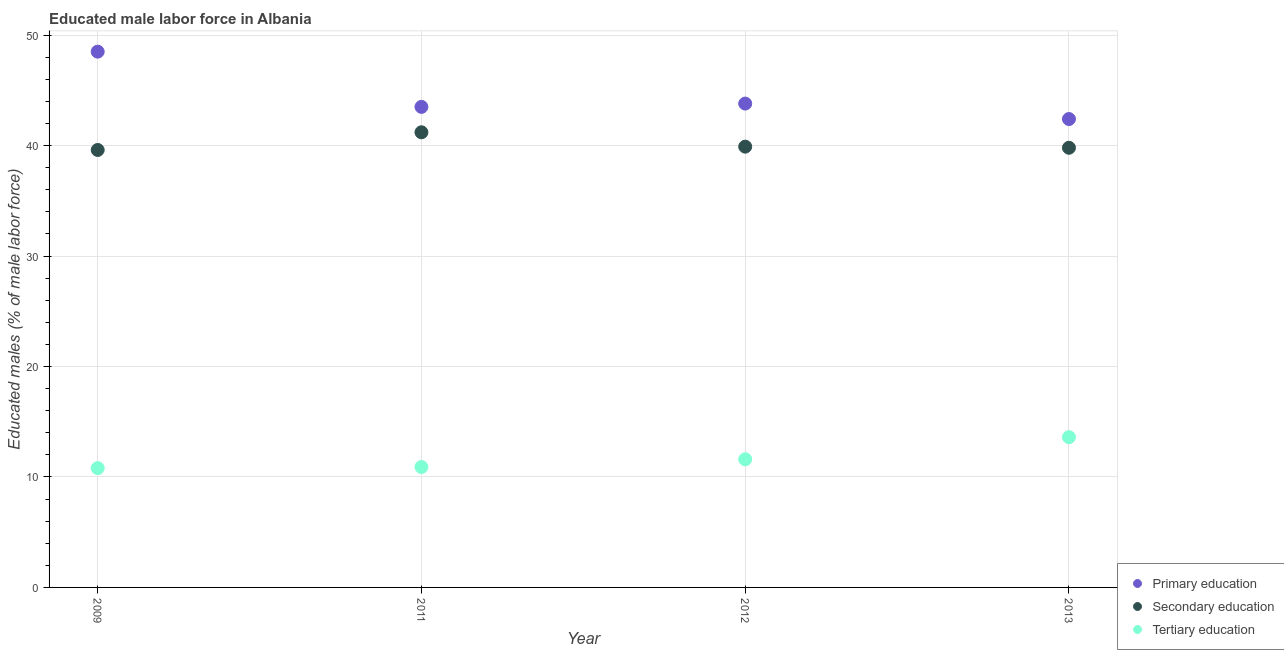Is the number of dotlines equal to the number of legend labels?
Keep it short and to the point. Yes. What is the percentage of male labor force who received secondary education in 2009?
Keep it short and to the point. 39.6. Across all years, what is the maximum percentage of male labor force who received primary education?
Keep it short and to the point. 48.5. Across all years, what is the minimum percentage of male labor force who received primary education?
Give a very brief answer. 42.4. In which year was the percentage of male labor force who received secondary education maximum?
Provide a short and direct response. 2011. What is the total percentage of male labor force who received primary education in the graph?
Ensure brevity in your answer.  178.2. What is the difference between the percentage of male labor force who received secondary education in 2011 and that in 2012?
Offer a terse response. 1.3. What is the difference between the percentage of male labor force who received secondary education in 2011 and the percentage of male labor force who received tertiary education in 2012?
Make the answer very short. 29.6. What is the average percentage of male labor force who received tertiary education per year?
Provide a short and direct response. 11.73. In the year 2009, what is the difference between the percentage of male labor force who received tertiary education and percentage of male labor force who received secondary education?
Ensure brevity in your answer.  -28.8. In how many years, is the percentage of male labor force who received secondary education greater than 16 %?
Your answer should be very brief. 4. What is the ratio of the percentage of male labor force who received tertiary education in 2009 to that in 2013?
Your response must be concise. 0.79. Is the percentage of male labor force who received secondary education in 2011 less than that in 2013?
Give a very brief answer. No. What is the difference between the highest and the second highest percentage of male labor force who received tertiary education?
Make the answer very short. 2. What is the difference between the highest and the lowest percentage of male labor force who received primary education?
Provide a succinct answer. 6.1. Is it the case that in every year, the sum of the percentage of male labor force who received primary education and percentage of male labor force who received secondary education is greater than the percentage of male labor force who received tertiary education?
Give a very brief answer. Yes. Is the percentage of male labor force who received tertiary education strictly greater than the percentage of male labor force who received primary education over the years?
Keep it short and to the point. No. Is the percentage of male labor force who received tertiary education strictly less than the percentage of male labor force who received primary education over the years?
Provide a short and direct response. Yes. How many dotlines are there?
Provide a short and direct response. 3. What is the difference between two consecutive major ticks on the Y-axis?
Your answer should be very brief. 10. Are the values on the major ticks of Y-axis written in scientific E-notation?
Offer a very short reply. No. Does the graph contain any zero values?
Your answer should be very brief. No. Does the graph contain grids?
Offer a terse response. Yes. What is the title of the graph?
Offer a terse response. Educated male labor force in Albania. What is the label or title of the X-axis?
Ensure brevity in your answer.  Year. What is the label or title of the Y-axis?
Keep it short and to the point. Educated males (% of male labor force). What is the Educated males (% of male labor force) in Primary education in 2009?
Your answer should be compact. 48.5. What is the Educated males (% of male labor force) of Secondary education in 2009?
Offer a terse response. 39.6. What is the Educated males (% of male labor force) of Tertiary education in 2009?
Your answer should be compact. 10.8. What is the Educated males (% of male labor force) in Primary education in 2011?
Provide a short and direct response. 43.5. What is the Educated males (% of male labor force) of Secondary education in 2011?
Your answer should be very brief. 41.2. What is the Educated males (% of male labor force) in Tertiary education in 2011?
Your response must be concise. 10.9. What is the Educated males (% of male labor force) of Primary education in 2012?
Offer a very short reply. 43.8. What is the Educated males (% of male labor force) in Secondary education in 2012?
Give a very brief answer. 39.9. What is the Educated males (% of male labor force) of Tertiary education in 2012?
Make the answer very short. 11.6. What is the Educated males (% of male labor force) in Primary education in 2013?
Ensure brevity in your answer.  42.4. What is the Educated males (% of male labor force) in Secondary education in 2013?
Provide a succinct answer. 39.8. What is the Educated males (% of male labor force) of Tertiary education in 2013?
Provide a short and direct response. 13.6. Across all years, what is the maximum Educated males (% of male labor force) in Primary education?
Make the answer very short. 48.5. Across all years, what is the maximum Educated males (% of male labor force) of Secondary education?
Keep it short and to the point. 41.2. Across all years, what is the maximum Educated males (% of male labor force) of Tertiary education?
Offer a terse response. 13.6. Across all years, what is the minimum Educated males (% of male labor force) in Primary education?
Offer a very short reply. 42.4. Across all years, what is the minimum Educated males (% of male labor force) in Secondary education?
Your answer should be very brief. 39.6. Across all years, what is the minimum Educated males (% of male labor force) in Tertiary education?
Your answer should be compact. 10.8. What is the total Educated males (% of male labor force) of Primary education in the graph?
Give a very brief answer. 178.2. What is the total Educated males (% of male labor force) in Secondary education in the graph?
Give a very brief answer. 160.5. What is the total Educated males (% of male labor force) in Tertiary education in the graph?
Keep it short and to the point. 46.9. What is the difference between the Educated males (% of male labor force) in Secondary education in 2009 and that in 2012?
Make the answer very short. -0.3. What is the difference between the Educated males (% of male labor force) in Primary education in 2009 and that in 2013?
Offer a very short reply. 6.1. What is the difference between the Educated males (% of male labor force) of Tertiary education in 2011 and that in 2012?
Give a very brief answer. -0.7. What is the difference between the Educated males (% of male labor force) of Primary education in 2011 and that in 2013?
Offer a very short reply. 1.1. What is the difference between the Educated males (% of male labor force) of Primary education in 2009 and the Educated males (% of male labor force) of Secondary education in 2011?
Offer a terse response. 7.3. What is the difference between the Educated males (% of male labor force) in Primary education in 2009 and the Educated males (% of male labor force) in Tertiary education in 2011?
Your response must be concise. 37.6. What is the difference between the Educated males (% of male labor force) in Secondary education in 2009 and the Educated males (% of male labor force) in Tertiary education in 2011?
Provide a succinct answer. 28.7. What is the difference between the Educated males (% of male labor force) in Primary education in 2009 and the Educated males (% of male labor force) in Secondary education in 2012?
Your answer should be compact. 8.6. What is the difference between the Educated males (% of male labor force) of Primary education in 2009 and the Educated males (% of male labor force) of Tertiary education in 2012?
Provide a short and direct response. 36.9. What is the difference between the Educated males (% of male labor force) of Primary education in 2009 and the Educated males (% of male labor force) of Tertiary education in 2013?
Make the answer very short. 34.9. What is the difference between the Educated males (% of male labor force) in Secondary education in 2009 and the Educated males (% of male labor force) in Tertiary education in 2013?
Offer a very short reply. 26. What is the difference between the Educated males (% of male labor force) of Primary education in 2011 and the Educated males (% of male labor force) of Tertiary education in 2012?
Provide a succinct answer. 31.9. What is the difference between the Educated males (% of male labor force) of Secondary education in 2011 and the Educated males (% of male labor force) of Tertiary education in 2012?
Provide a short and direct response. 29.6. What is the difference between the Educated males (% of male labor force) of Primary education in 2011 and the Educated males (% of male labor force) of Tertiary education in 2013?
Provide a succinct answer. 29.9. What is the difference between the Educated males (% of male labor force) in Secondary education in 2011 and the Educated males (% of male labor force) in Tertiary education in 2013?
Ensure brevity in your answer.  27.6. What is the difference between the Educated males (% of male labor force) of Primary education in 2012 and the Educated males (% of male labor force) of Secondary education in 2013?
Your answer should be compact. 4. What is the difference between the Educated males (% of male labor force) of Primary education in 2012 and the Educated males (% of male labor force) of Tertiary education in 2013?
Ensure brevity in your answer.  30.2. What is the difference between the Educated males (% of male labor force) in Secondary education in 2012 and the Educated males (% of male labor force) in Tertiary education in 2013?
Make the answer very short. 26.3. What is the average Educated males (% of male labor force) in Primary education per year?
Provide a short and direct response. 44.55. What is the average Educated males (% of male labor force) in Secondary education per year?
Keep it short and to the point. 40.12. What is the average Educated males (% of male labor force) in Tertiary education per year?
Your answer should be compact. 11.72. In the year 2009, what is the difference between the Educated males (% of male labor force) of Primary education and Educated males (% of male labor force) of Secondary education?
Provide a succinct answer. 8.9. In the year 2009, what is the difference between the Educated males (% of male labor force) in Primary education and Educated males (% of male labor force) in Tertiary education?
Provide a short and direct response. 37.7. In the year 2009, what is the difference between the Educated males (% of male labor force) of Secondary education and Educated males (% of male labor force) of Tertiary education?
Give a very brief answer. 28.8. In the year 2011, what is the difference between the Educated males (% of male labor force) in Primary education and Educated males (% of male labor force) in Tertiary education?
Ensure brevity in your answer.  32.6. In the year 2011, what is the difference between the Educated males (% of male labor force) in Secondary education and Educated males (% of male labor force) in Tertiary education?
Keep it short and to the point. 30.3. In the year 2012, what is the difference between the Educated males (% of male labor force) of Primary education and Educated males (% of male labor force) of Tertiary education?
Your response must be concise. 32.2. In the year 2012, what is the difference between the Educated males (% of male labor force) in Secondary education and Educated males (% of male labor force) in Tertiary education?
Give a very brief answer. 28.3. In the year 2013, what is the difference between the Educated males (% of male labor force) in Primary education and Educated males (% of male labor force) in Secondary education?
Offer a very short reply. 2.6. In the year 2013, what is the difference between the Educated males (% of male labor force) in Primary education and Educated males (% of male labor force) in Tertiary education?
Your response must be concise. 28.8. In the year 2013, what is the difference between the Educated males (% of male labor force) in Secondary education and Educated males (% of male labor force) in Tertiary education?
Your answer should be compact. 26.2. What is the ratio of the Educated males (% of male labor force) of Primary education in 2009 to that in 2011?
Make the answer very short. 1.11. What is the ratio of the Educated males (% of male labor force) of Secondary education in 2009 to that in 2011?
Your answer should be compact. 0.96. What is the ratio of the Educated males (% of male labor force) of Primary education in 2009 to that in 2012?
Your answer should be very brief. 1.11. What is the ratio of the Educated males (% of male labor force) of Primary education in 2009 to that in 2013?
Keep it short and to the point. 1.14. What is the ratio of the Educated males (% of male labor force) of Tertiary education in 2009 to that in 2013?
Make the answer very short. 0.79. What is the ratio of the Educated males (% of male labor force) in Primary education in 2011 to that in 2012?
Offer a terse response. 0.99. What is the ratio of the Educated males (% of male labor force) of Secondary education in 2011 to that in 2012?
Provide a succinct answer. 1.03. What is the ratio of the Educated males (% of male labor force) of Tertiary education in 2011 to that in 2012?
Provide a succinct answer. 0.94. What is the ratio of the Educated males (% of male labor force) of Primary education in 2011 to that in 2013?
Make the answer very short. 1.03. What is the ratio of the Educated males (% of male labor force) of Secondary education in 2011 to that in 2013?
Provide a short and direct response. 1.04. What is the ratio of the Educated males (% of male labor force) of Tertiary education in 2011 to that in 2013?
Give a very brief answer. 0.8. What is the ratio of the Educated males (% of male labor force) in Primary education in 2012 to that in 2013?
Offer a very short reply. 1.03. What is the ratio of the Educated males (% of male labor force) in Secondary education in 2012 to that in 2013?
Offer a very short reply. 1. What is the ratio of the Educated males (% of male labor force) of Tertiary education in 2012 to that in 2013?
Offer a very short reply. 0.85. What is the difference between the highest and the lowest Educated males (% of male labor force) in Secondary education?
Offer a very short reply. 1.6. 